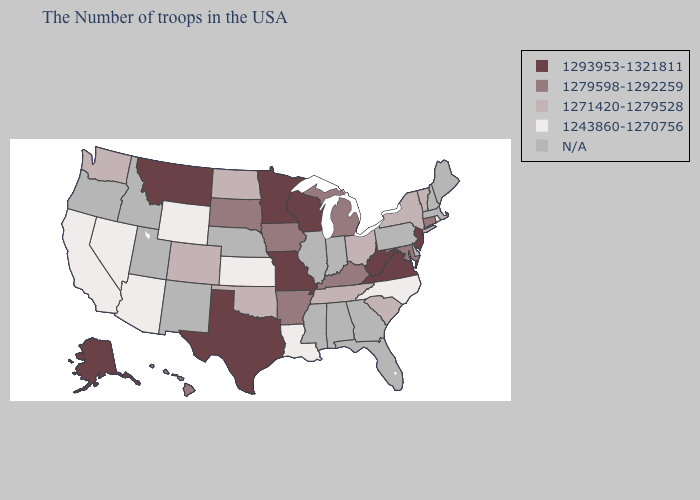What is the value of Michigan?
Short answer required. 1279598-1292259. Name the states that have a value in the range 1279598-1292259?
Short answer required. Connecticut, Maryland, Michigan, Kentucky, Arkansas, Iowa, South Dakota, Hawaii. Name the states that have a value in the range 1271420-1279528?
Give a very brief answer. Vermont, New York, South Carolina, Ohio, Tennessee, Oklahoma, North Dakota, Colorado, Washington. Does New York have the lowest value in the Northeast?
Short answer required. No. Among the states that border Virginia , which have the highest value?
Concise answer only. West Virginia. What is the highest value in the USA?
Give a very brief answer. 1293953-1321811. What is the lowest value in states that border West Virginia?
Give a very brief answer. 1271420-1279528. Name the states that have a value in the range 1279598-1292259?
Short answer required. Connecticut, Maryland, Michigan, Kentucky, Arkansas, Iowa, South Dakota, Hawaii. What is the value of Georgia?
Answer briefly. N/A. What is the value of Pennsylvania?
Concise answer only. N/A. Name the states that have a value in the range 1243860-1270756?
Quick response, please. Rhode Island, North Carolina, Louisiana, Kansas, Wyoming, Arizona, Nevada, California. What is the value of Maryland?
Answer briefly. 1279598-1292259. Among the states that border Texas , does Arkansas have the highest value?
Short answer required. Yes. 